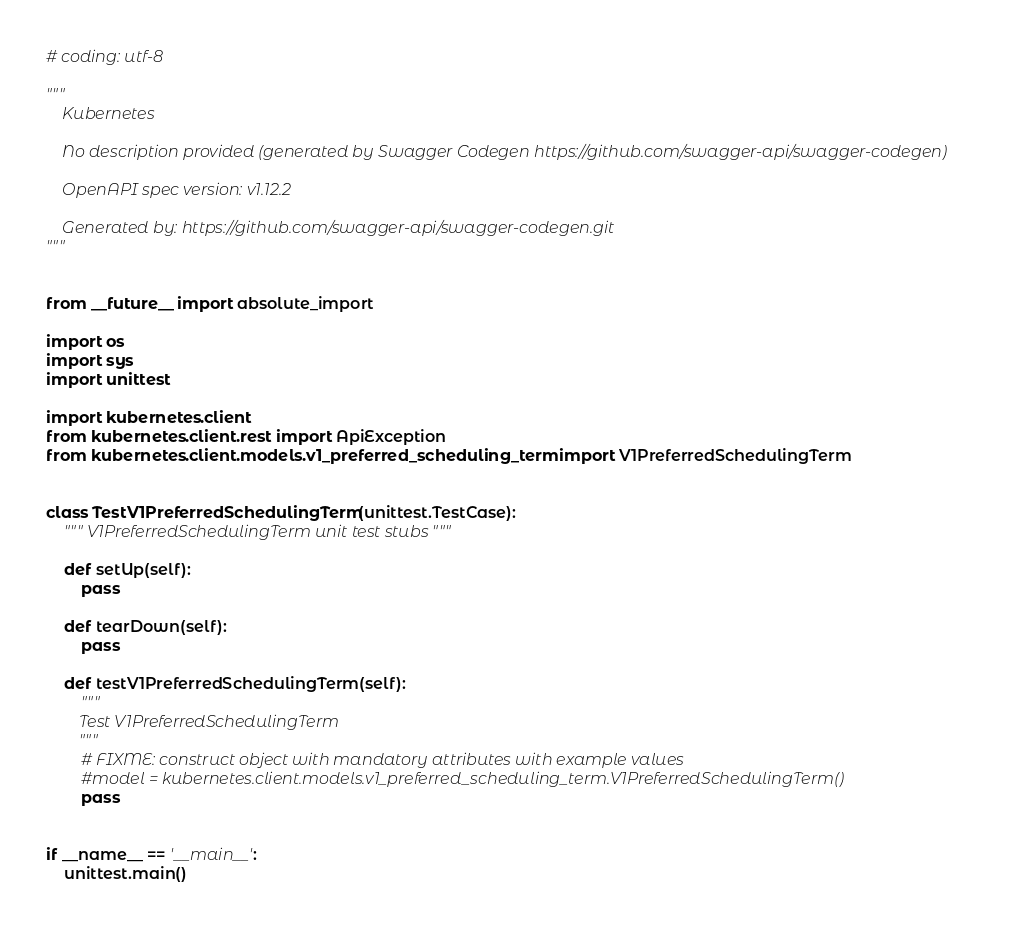<code> <loc_0><loc_0><loc_500><loc_500><_Python_># coding: utf-8

"""
    Kubernetes

    No description provided (generated by Swagger Codegen https://github.com/swagger-api/swagger-codegen)

    OpenAPI spec version: v1.12.2
    
    Generated by: https://github.com/swagger-api/swagger-codegen.git
"""


from __future__ import absolute_import

import os
import sys
import unittest

import kubernetes.client
from kubernetes.client.rest import ApiException
from kubernetes.client.models.v1_preferred_scheduling_term import V1PreferredSchedulingTerm


class TestV1PreferredSchedulingTerm(unittest.TestCase):
    """ V1PreferredSchedulingTerm unit test stubs """

    def setUp(self):
        pass

    def tearDown(self):
        pass

    def testV1PreferredSchedulingTerm(self):
        """
        Test V1PreferredSchedulingTerm
        """
        # FIXME: construct object with mandatory attributes with example values
        #model = kubernetes.client.models.v1_preferred_scheduling_term.V1PreferredSchedulingTerm()
        pass


if __name__ == '__main__':
    unittest.main()
</code> 